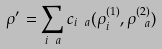Convert formula to latex. <formula><loc_0><loc_0><loc_500><loc_500>\rho ^ { \prime } = \sum _ { i \ a } c _ { i \ a } ( \rho ^ { ( 1 ) } _ { i } , \rho ^ { ( 2 ) } _ { \ a } )</formula> 